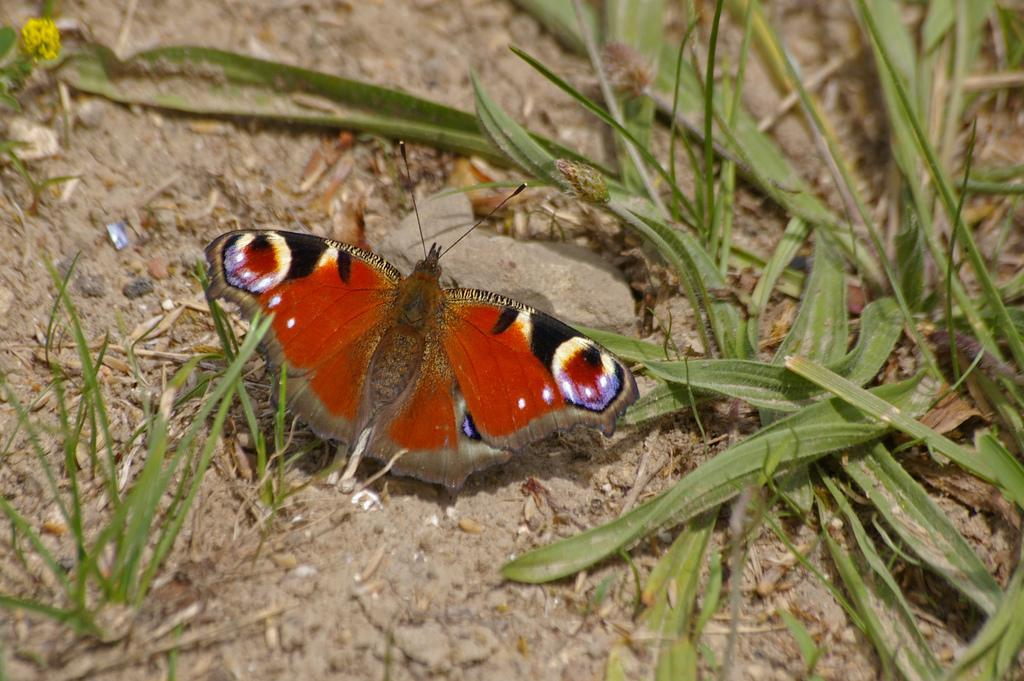What type of animal can be seen in the image? There is a butterfly with wings in the image. What is the small object in the image? There is a small stone in the image. What type of vegetation is present in the image? There are leaves lying on the ground in the image. What type of shirt is the butterfly wearing in the image? Butterflies do not wear shirts, as they are insects and do not have the ability to wear clothing. Are there any trousers visible in the image? There are no trousers present in the image, as it features a butterfly and a small stone, not human clothing. 